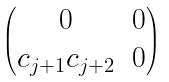<formula> <loc_0><loc_0><loc_500><loc_500>\begin{pmatrix} 0 & 0 \\ { c } _ { j + 1 } c _ { j + 2 } & 0 \\ \end{pmatrix}</formula> 